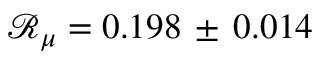<formula> <loc_0><loc_0><loc_500><loc_500>\mathcal { R } _ { \mu } = 0 . 1 9 8 \, \pm \, 0 . 0 1 4</formula> 